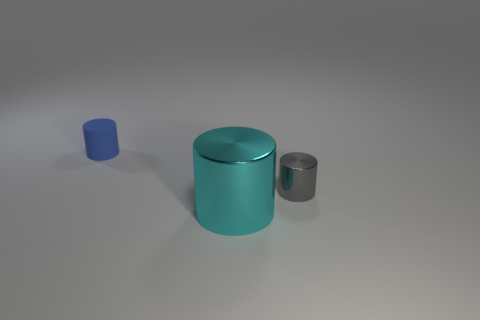Subtract all tiny metallic cylinders. How many cylinders are left? 2 Subtract 3 cylinders. How many cylinders are left? 0 Subtract all purple cylinders. Subtract all gray balls. How many cylinders are left? 3 Subtract all red cubes. How many gray cylinders are left? 1 Subtract all large green matte objects. Subtract all blue matte objects. How many objects are left? 2 Add 1 cyan shiny cylinders. How many cyan shiny cylinders are left? 2 Add 3 tiny shiny cylinders. How many tiny shiny cylinders exist? 4 Add 3 tiny blue rubber objects. How many objects exist? 6 Subtract all gray cylinders. How many cylinders are left? 2 Subtract 0 brown cubes. How many objects are left? 3 